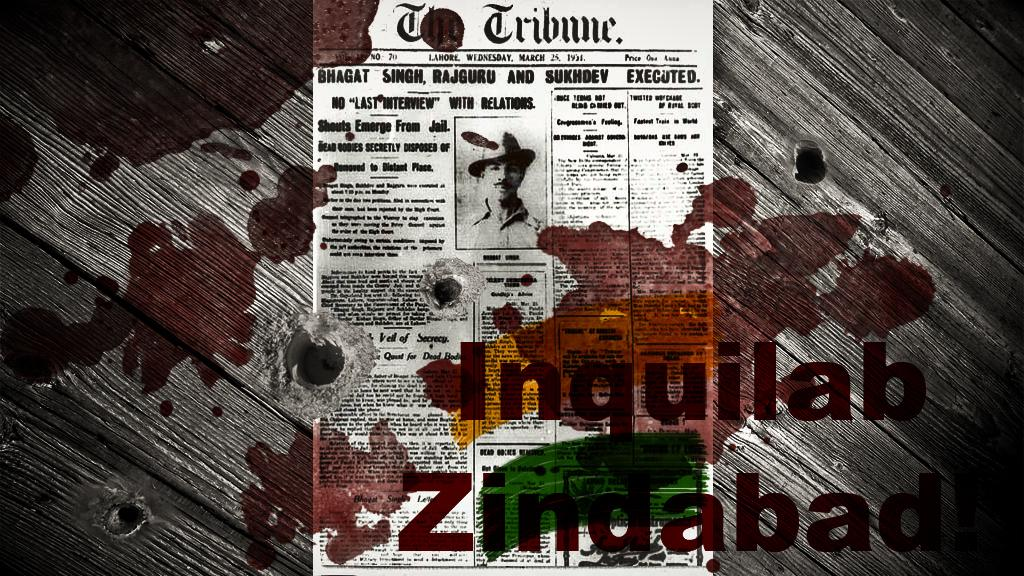Provide a one-sentence caption for the provided image. A copy of the newspaper the tribune is covered in red stains. 